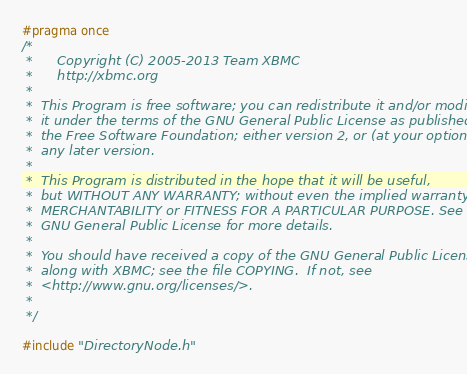Convert code to text. <code><loc_0><loc_0><loc_500><loc_500><_C_>#pragma once
/*
 *      Copyright (C) 2005-2013 Team XBMC
 *      http://xbmc.org
 *
 *  This Program is free software; you can redistribute it and/or modify
 *  it under the terms of the GNU General Public License as published by
 *  the Free Software Foundation; either version 2, or (at your option)
 *  any later version.
 *
 *  This Program is distributed in the hope that it will be useful,
 *  but WITHOUT ANY WARRANTY; without even the implied warranty of
 *  MERCHANTABILITY or FITNESS FOR A PARTICULAR PURPOSE. See the
 *  GNU General Public License for more details.
 *
 *  You should have received a copy of the GNU General Public License
 *  along with XBMC; see the file COPYING.  If not, see
 *  <http://www.gnu.org/licenses/>.
 *
 */

#include "DirectoryNode.h"
</code> 